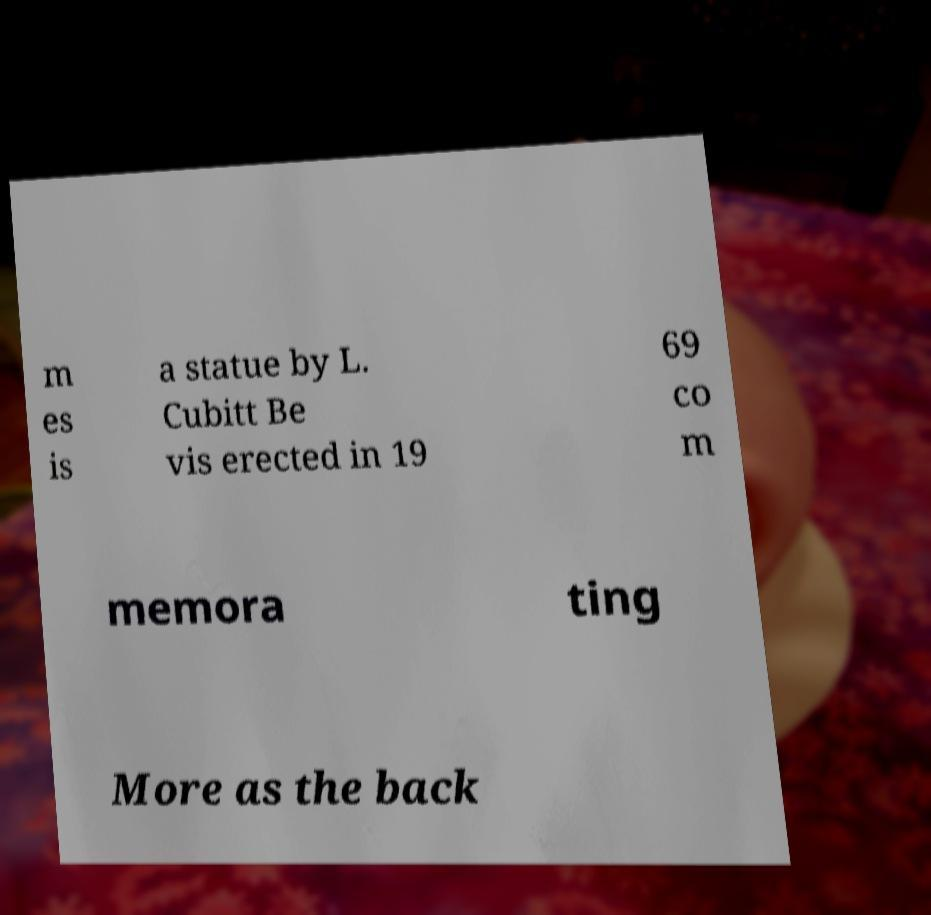Please read and relay the text visible in this image. What does it say? m es is a statue by L. Cubitt Be vis erected in 19 69 co m memora ting More as the back 